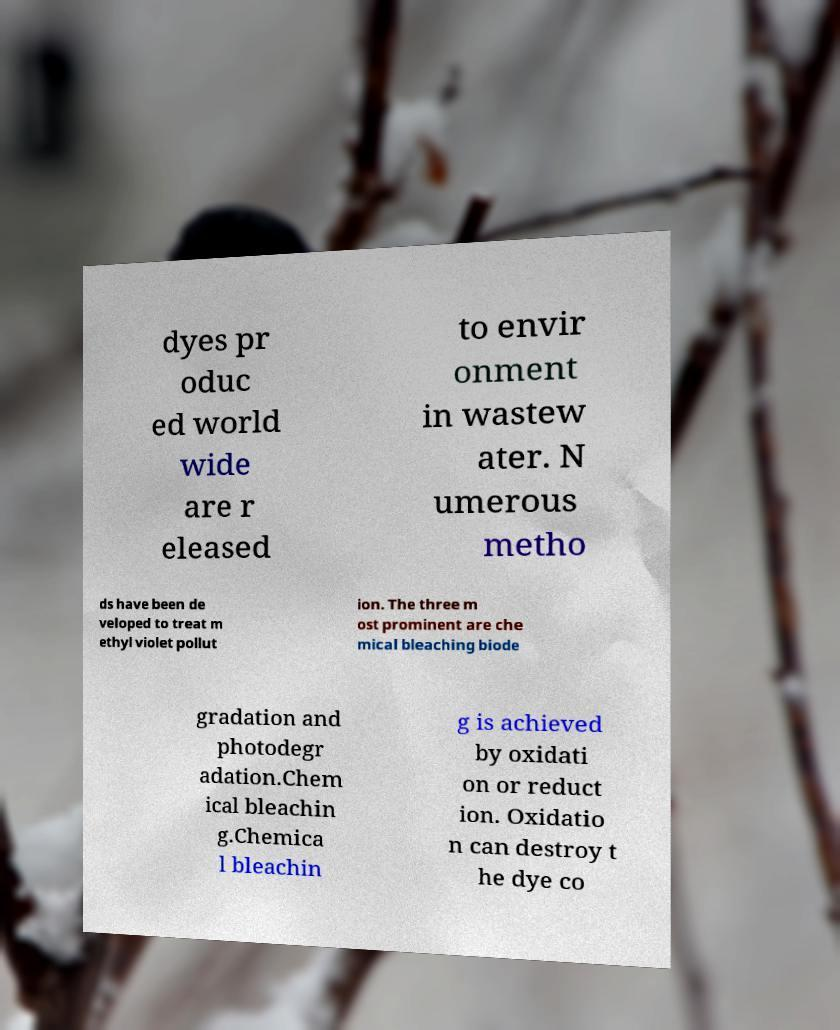What messages or text are displayed in this image? I need them in a readable, typed format. dyes pr oduc ed world wide are r eleased to envir onment in wastew ater. N umerous metho ds have been de veloped to treat m ethyl violet pollut ion. The three m ost prominent are che mical bleaching biode gradation and photodegr adation.Chem ical bleachin g.Chemica l bleachin g is achieved by oxidati on or reduct ion. Oxidatio n can destroy t he dye co 